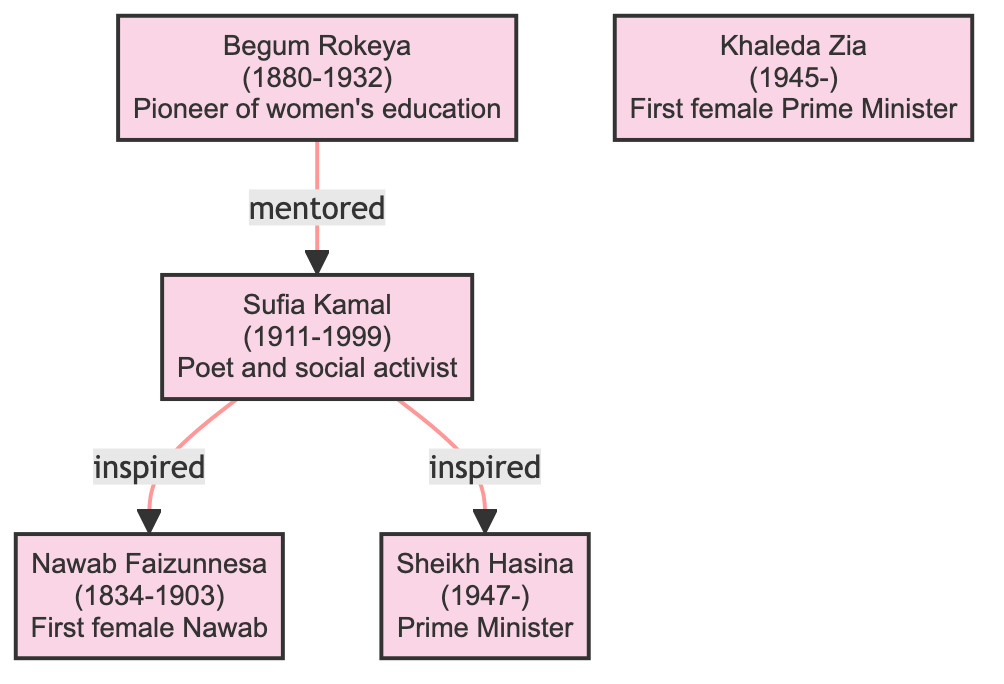What is the birth year of Begum Rokeya? The diagram lists Begum Rokeya's birth year directly as 1880, which is noted right below her name and before her death year.
Answer: 1880 Who mentored Sufia Kamal? The arrow pointing from Begum Rokeya to Sufia Kamal indicates that Begum Rokeya is the one who mentored Sufia Kamal, as labeled in the relationship section.
Answer: Begum Rokeya What is the contribution of Sheikh Hasina? The diagram specifies Sheikh Hasina's contribution as "Prime Minister of Bangladesh, instrumental in passing women-friendly policies," located directly under her name.
Answer: Prime Minister of Bangladesh, instrumental in passing women-friendly policies How many descendants does Sufia Kamal have? The diagram shows two arrows emerging from Sufia Kamal pointing towards Nawab Faizunnesa and Sheikh Hasina, indicating that she has two descendants.
Answer: 2 Who was inspired by Sufia Kamal? The arrows point to both Nawab Faizunnesa and Sheikh Hasina from Sufia Kamal, confirming that both were inspired by her, as indicated in the relationships section.
Answer: Nawab Faizunnesa and Sheikh Hasina What year did Khaleda Zia become the first female Prime Minister? The diagram does not specify the exact year she became the Prime Minister; however, as she was born in 1945 and is noted as the first female Prime Minister, this title and role are inferred from her entry.
Answer: First female Prime Minister Which person in the diagram was born in 1834? The birth year 1834 is clearly attributed to Nawab Faizunnesa, as indicated in her section in the diagram.
Answer: Nawab Faizunnesa Between which two figures is the relationship labeled "inspired"? The arrows labeled "inspired" connect Sufia Kamal to both Nawab Faizunnesa and Sheikh Hasina, forming the relationship pairs noted in the diagram.
Answer: Sufia Kamal and Nawab Faizunnesa, Sufia Kamal and Sheikh Hasina What did Begum Rokeya advocate for? The diagram highlights that Begum Rokeya was a pioneer of women's education and social reform in Bengal, summarizing her key contributions beneath her name.
Answer: Women's education and social reform 